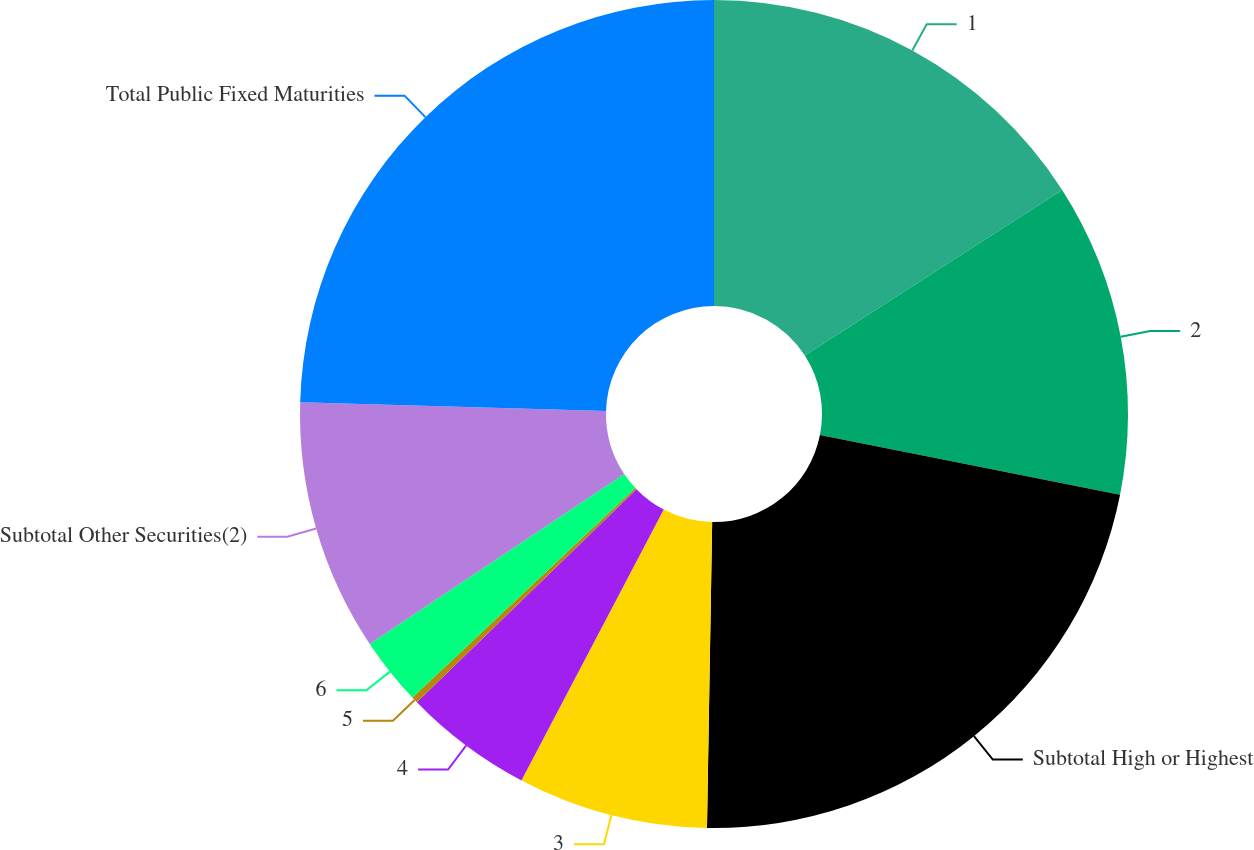<chart> <loc_0><loc_0><loc_500><loc_500><pie_chart><fcel>1<fcel>2<fcel>Subtotal High or Highest<fcel>3<fcel>4<fcel>5<fcel>6<fcel>Subtotal Other Securities(2)<fcel>Total Public Fixed Maturities<nl><fcel>15.9%<fcel>12.22%<fcel>22.15%<fcel>7.43%<fcel>5.04%<fcel>0.25%<fcel>2.64%<fcel>9.82%<fcel>24.55%<nl></chart> 